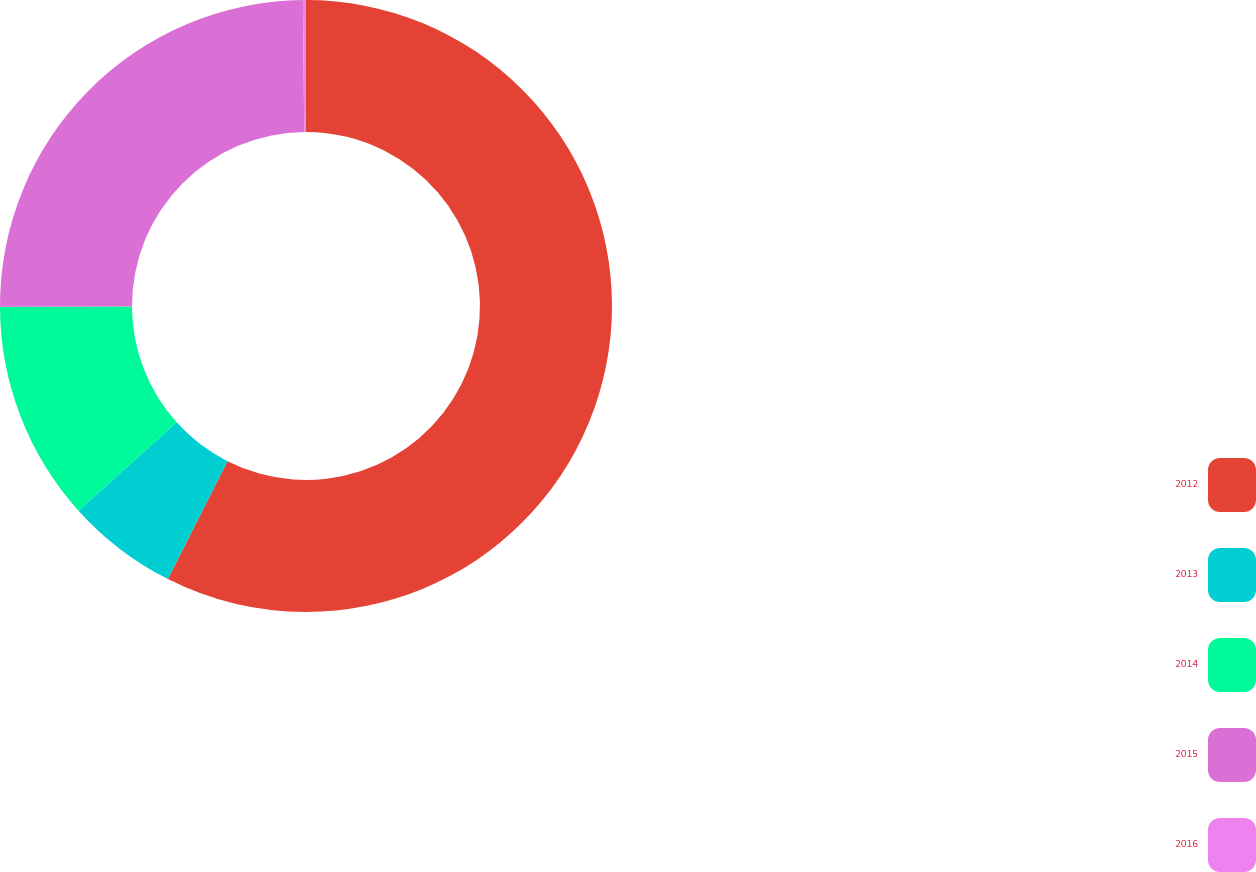Convert chart to OTSL. <chart><loc_0><loc_0><loc_500><loc_500><pie_chart><fcel>2012<fcel>2013<fcel>2014<fcel>2015<fcel>2016<nl><fcel>57.45%<fcel>5.89%<fcel>11.62%<fcel>24.88%<fcel>0.16%<nl></chart> 